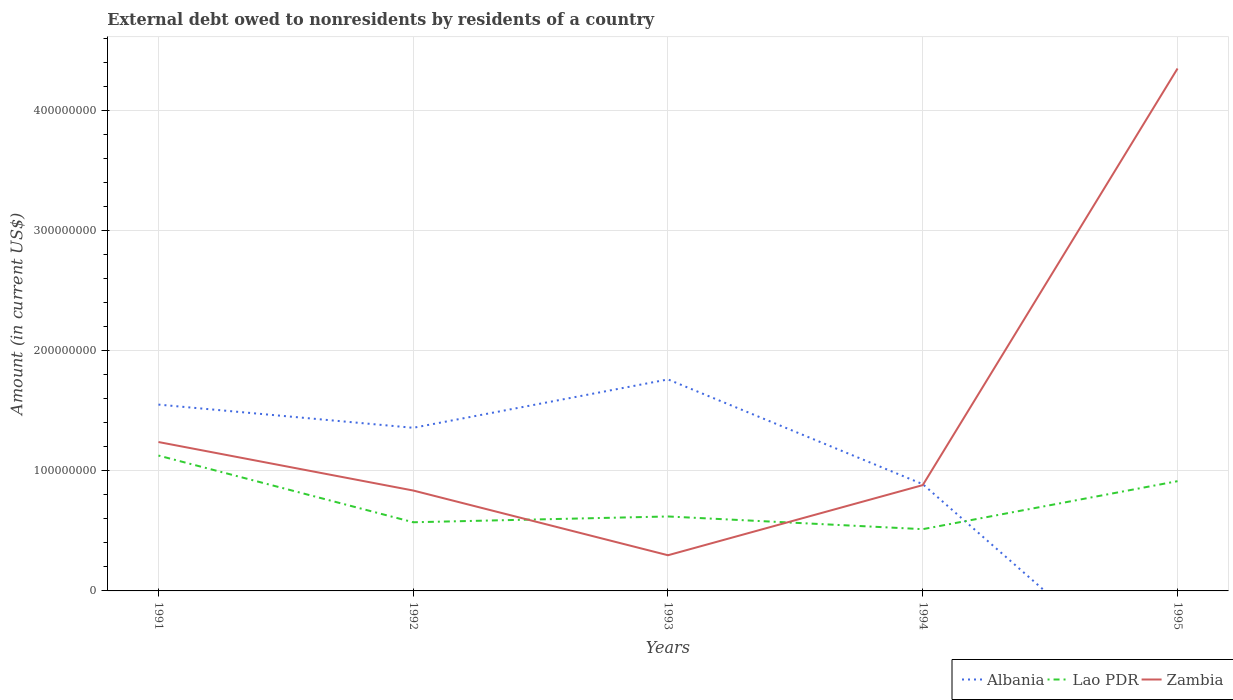Does the line corresponding to Albania intersect with the line corresponding to Lao PDR?
Make the answer very short. Yes. Across all years, what is the maximum external debt owed by residents in Lao PDR?
Provide a succinct answer. 5.14e+07. What is the total external debt owed by residents in Zambia in the graph?
Provide a short and direct response. -4.05e+08. What is the difference between the highest and the second highest external debt owed by residents in Albania?
Give a very brief answer. 1.76e+08. Is the external debt owed by residents in Zambia strictly greater than the external debt owed by residents in Albania over the years?
Ensure brevity in your answer.  No. How are the legend labels stacked?
Make the answer very short. Horizontal. What is the title of the graph?
Give a very brief answer. External debt owed to nonresidents by residents of a country. What is the label or title of the X-axis?
Provide a short and direct response. Years. What is the label or title of the Y-axis?
Keep it short and to the point. Amount (in current US$). What is the Amount (in current US$) in Albania in 1991?
Your answer should be very brief. 1.55e+08. What is the Amount (in current US$) of Lao PDR in 1991?
Provide a succinct answer. 1.13e+08. What is the Amount (in current US$) in Zambia in 1991?
Offer a terse response. 1.24e+08. What is the Amount (in current US$) of Albania in 1992?
Give a very brief answer. 1.36e+08. What is the Amount (in current US$) of Lao PDR in 1992?
Provide a succinct answer. 5.72e+07. What is the Amount (in current US$) in Zambia in 1992?
Keep it short and to the point. 8.36e+07. What is the Amount (in current US$) of Albania in 1993?
Keep it short and to the point. 1.76e+08. What is the Amount (in current US$) of Lao PDR in 1993?
Ensure brevity in your answer.  6.20e+07. What is the Amount (in current US$) in Zambia in 1993?
Provide a succinct answer. 2.97e+07. What is the Amount (in current US$) in Albania in 1994?
Provide a short and direct response. 8.89e+07. What is the Amount (in current US$) of Lao PDR in 1994?
Provide a succinct answer. 5.14e+07. What is the Amount (in current US$) in Zambia in 1994?
Offer a very short reply. 8.81e+07. What is the Amount (in current US$) in Lao PDR in 1995?
Give a very brief answer. 9.14e+07. What is the Amount (in current US$) in Zambia in 1995?
Your answer should be compact. 4.35e+08. Across all years, what is the maximum Amount (in current US$) in Albania?
Keep it short and to the point. 1.76e+08. Across all years, what is the maximum Amount (in current US$) in Lao PDR?
Ensure brevity in your answer.  1.13e+08. Across all years, what is the maximum Amount (in current US$) of Zambia?
Offer a very short reply. 4.35e+08. Across all years, what is the minimum Amount (in current US$) of Albania?
Ensure brevity in your answer.  0. Across all years, what is the minimum Amount (in current US$) of Lao PDR?
Provide a short and direct response. 5.14e+07. Across all years, what is the minimum Amount (in current US$) of Zambia?
Offer a terse response. 2.97e+07. What is the total Amount (in current US$) in Albania in the graph?
Your answer should be very brief. 5.56e+08. What is the total Amount (in current US$) of Lao PDR in the graph?
Offer a very short reply. 3.75e+08. What is the total Amount (in current US$) of Zambia in the graph?
Your answer should be compact. 7.60e+08. What is the difference between the Amount (in current US$) in Albania in 1991 and that in 1992?
Your answer should be very brief. 1.93e+07. What is the difference between the Amount (in current US$) of Lao PDR in 1991 and that in 1992?
Provide a succinct answer. 5.55e+07. What is the difference between the Amount (in current US$) of Zambia in 1991 and that in 1992?
Give a very brief answer. 4.04e+07. What is the difference between the Amount (in current US$) in Albania in 1991 and that in 1993?
Make the answer very short. -2.10e+07. What is the difference between the Amount (in current US$) of Lao PDR in 1991 and that in 1993?
Make the answer very short. 5.07e+07. What is the difference between the Amount (in current US$) of Zambia in 1991 and that in 1993?
Keep it short and to the point. 9.43e+07. What is the difference between the Amount (in current US$) of Albania in 1991 and that in 1994?
Provide a short and direct response. 6.63e+07. What is the difference between the Amount (in current US$) of Lao PDR in 1991 and that in 1994?
Provide a succinct answer. 6.13e+07. What is the difference between the Amount (in current US$) of Zambia in 1991 and that in 1994?
Offer a very short reply. 3.59e+07. What is the difference between the Amount (in current US$) of Lao PDR in 1991 and that in 1995?
Offer a terse response. 2.13e+07. What is the difference between the Amount (in current US$) of Zambia in 1991 and that in 1995?
Your response must be concise. -3.11e+08. What is the difference between the Amount (in current US$) in Albania in 1992 and that in 1993?
Your answer should be very brief. -4.03e+07. What is the difference between the Amount (in current US$) of Lao PDR in 1992 and that in 1993?
Give a very brief answer. -4.82e+06. What is the difference between the Amount (in current US$) in Zambia in 1992 and that in 1993?
Keep it short and to the point. 5.39e+07. What is the difference between the Amount (in current US$) in Albania in 1992 and that in 1994?
Your answer should be compact. 4.69e+07. What is the difference between the Amount (in current US$) of Lao PDR in 1992 and that in 1994?
Ensure brevity in your answer.  5.76e+06. What is the difference between the Amount (in current US$) in Zambia in 1992 and that in 1994?
Your response must be concise. -4.52e+06. What is the difference between the Amount (in current US$) in Lao PDR in 1992 and that in 1995?
Your response must be concise. -3.42e+07. What is the difference between the Amount (in current US$) of Zambia in 1992 and that in 1995?
Offer a very short reply. -3.51e+08. What is the difference between the Amount (in current US$) of Albania in 1993 and that in 1994?
Offer a terse response. 8.72e+07. What is the difference between the Amount (in current US$) in Lao PDR in 1993 and that in 1994?
Provide a short and direct response. 1.06e+07. What is the difference between the Amount (in current US$) of Zambia in 1993 and that in 1994?
Make the answer very short. -5.84e+07. What is the difference between the Amount (in current US$) of Lao PDR in 1993 and that in 1995?
Give a very brief answer. -2.94e+07. What is the difference between the Amount (in current US$) of Zambia in 1993 and that in 1995?
Give a very brief answer. -4.05e+08. What is the difference between the Amount (in current US$) in Lao PDR in 1994 and that in 1995?
Provide a short and direct response. -4.00e+07. What is the difference between the Amount (in current US$) in Zambia in 1994 and that in 1995?
Offer a terse response. -3.47e+08. What is the difference between the Amount (in current US$) in Albania in 1991 and the Amount (in current US$) in Lao PDR in 1992?
Ensure brevity in your answer.  9.80e+07. What is the difference between the Amount (in current US$) of Albania in 1991 and the Amount (in current US$) of Zambia in 1992?
Your answer should be very brief. 7.15e+07. What is the difference between the Amount (in current US$) of Lao PDR in 1991 and the Amount (in current US$) of Zambia in 1992?
Give a very brief answer. 2.91e+07. What is the difference between the Amount (in current US$) in Albania in 1991 and the Amount (in current US$) in Lao PDR in 1993?
Your answer should be very brief. 9.31e+07. What is the difference between the Amount (in current US$) of Albania in 1991 and the Amount (in current US$) of Zambia in 1993?
Your response must be concise. 1.25e+08. What is the difference between the Amount (in current US$) in Lao PDR in 1991 and the Amount (in current US$) in Zambia in 1993?
Offer a terse response. 8.30e+07. What is the difference between the Amount (in current US$) of Albania in 1991 and the Amount (in current US$) of Lao PDR in 1994?
Make the answer very short. 1.04e+08. What is the difference between the Amount (in current US$) in Albania in 1991 and the Amount (in current US$) in Zambia in 1994?
Ensure brevity in your answer.  6.70e+07. What is the difference between the Amount (in current US$) in Lao PDR in 1991 and the Amount (in current US$) in Zambia in 1994?
Give a very brief answer. 2.46e+07. What is the difference between the Amount (in current US$) in Albania in 1991 and the Amount (in current US$) in Lao PDR in 1995?
Offer a very short reply. 6.38e+07. What is the difference between the Amount (in current US$) in Albania in 1991 and the Amount (in current US$) in Zambia in 1995?
Your response must be concise. -2.80e+08. What is the difference between the Amount (in current US$) of Lao PDR in 1991 and the Amount (in current US$) of Zambia in 1995?
Your answer should be very brief. -3.22e+08. What is the difference between the Amount (in current US$) in Albania in 1992 and the Amount (in current US$) in Lao PDR in 1993?
Give a very brief answer. 7.38e+07. What is the difference between the Amount (in current US$) of Albania in 1992 and the Amount (in current US$) of Zambia in 1993?
Provide a succinct answer. 1.06e+08. What is the difference between the Amount (in current US$) of Lao PDR in 1992 and the Amount (in current US$) of Zambia in 1993?
Your answer should be very brief. 2.75e+07. What is the difference between the Amount (in current US$) of Albania in 1992 and the Amount (in current US$) of Lao PDR in 1994?
Your answer should be very brief. 8.44e+07. What is the difference between the Amount (in current US$) in Albania in 1992 and the Amount (in current US$) in Zambia in 1994?
Offer a very short reply. 4.77e+07. What is the difference between the Amount (in current US$) of Lao PDR in 1992 and the Amount (in current US$) of Zambia in 1994?
Offer a terse response. -3.09e+07. What is the difference between the Amount (in current US$) of Albania in 1992 and the Amount (in current US$) of Lao PDR in 1995?
Give a very brief answer. 4.44e+07. What is the difference between the Amount (in current US$) of Albania in 1992 and the Amount (in current US$) of Zambia in 1995?
Keep it short and to the point. -2.99e+08. What is the difference between the Amount (in current US$) of Lao PDR in 1992 and the Amount (in current US$) of Zambia in 1995?
Offer a very short reply. -3.78e+08. What is the difference between the Amount (in current US$) in Albania in 1993 and the Amount (in current US$) in Lao PDR in 1994?
Your answer should be very brief. 1.25e+08. What is the difference between the Amount (in current US$) of Albania in 1993 and the Amount (in current US$) of Zambia in 1994?
Your answer should be very brief. 8.80e+07. What is the difference between the Amount (in current US$) in Lao PDR in 1993 and the Amount (in current US$) in Zambia in 1994?
Your answer should be compact. -2.61e+07. What is the difference between the Amount (in current US$) in Albania in 1993 and the Amount (in current US$) in Lao PDR in 1995?
Your answer should be compact. 8.47e+07. What is the difference between the Amount (in current US$) in Albania in 1993 and the Amount (in current US$) in Zambia in 1995?
Offer a terse response. -2.59e+08. What is the difference between the Amount (in current US$) in Lao PDR in 1993 and the Amount (in current US$) in Zambia in 1995?
Offer a very short reply. -3.73e+08. What is the difference between the Amount (in current US$) of Albania in 1994 and the Amount (in current US$) of Lao PDR in 1995?
Your answer should be compact. -2.50e+06. What is the difference between the Amount (in current US$) in Albania in 1994 and the Amount (in current US$) in Zambia in 1995?
Provide a short and direct response. -3.46e+08. What is the difference between the Amount (in current US$) in Lao PDR in 1994 and the Amount (in current US$) in Zambia in 1995?
Make the answer very short. -3.84e+08. What is the average Amount (in current US$) in Albania per year?
Offer a very short reply. 1.11e+08. What is the average Amount (in current US$) in Lao PDR per year?
Your answer should be compact. 7.49e+07. What is the average Amount (in current US$) in Zambia per year?
Offer a very short reply. 1.52e+08. In the year 1991, what is the difference between the Amount (in current US$) in Albania and Amount (in current US$) in Lao PDR?
Make the answer very short. 4.24e+07. In the year 1991, what is the difference between the Amount (in current US$) of Albania and Amount (in current US$) of Zambia?
Your answer should be very brief. 3.12e+07. In the year 1991, what is the difference between the Amount (in current US$) in Lao PDR and Amount (in current US$) in Zambia?
Keep it short and to the point. -1.13e+07. In the year 1992, what is the difference between the Amount (in current US$) of Albania and Amount (in current US$) of Lao PDR?
Your answer should be compact. 7.86e+07. In the year 1992, what is the difference between the Amount (in current US$) in Albania and Amount (in current US$) in Zambia?
Your answer should be compact. 5.22e+07. In the year 1992, what is the difference between the Amount (in current US$) in Lao PDR and Amount (in current US$) in Zambia?
Make the answer very short. -2.64e+07. In the year 1993, what is the difference between the Amount (in current US$) of Albania and Amount (in current US$) of Lao PDR?
Your answer should be very brief. 1.14e+08. In the year 1993, what is the difference between the Amount (in current US$) in Albania and Amount (in current US$) in Zambia?
Give a very brief answer. 1.46e+08. In the year 1993, what is the difference between the Amount (in current US$) in Lao PDR and Amount (in current US$) in Zambia?
Your response must be concise. 3.23e+07. In the year 1994, what is the difference between the Amount (in current US$) in Albania and Amount (in current US$) in Lao PDR?
Provide a succinct answer. 3.75e+07. In the year 1994, what is the difference between the Amount (in current US$) in Albania and Amount (in current US$) in Zambia?
Your answer should be compact. 7.77e+05. In the year 1994, what is the difference between the Amount (in current US$) in Lao PDR and Amount (in current US$) in Zambia?
Your response must be concise. -3.67e+07. In the year 1995, what is the difference between the Amount (in current US$) in Lao PDR and Amount (in current US$) in Zambia?
Your answer should be very brief. -3.44e+08. What is the ratio of the Amount (in current US$) of Albania in 1991 to that in 1992?
Provide a succinct answer. 1.14. What is the ratio of the Amount (in current US$) of Lao PDR in 1991 to that in 1992?
Your answer should be very brief. 1.97. What is the ratio of the Amount (in current US$) of Zambia in 1991 to that in 1992?
Your answer should be compact. 1.48. What is the ratio of the Amount (in current US$) of Albania in 1991 to that in 1993?
Provide a short and direct response. 0.88. What is the ratio of the Amount (in current US$) of Lao PDR in 1991 to that in 1993?
Ensure brevity in your answer.  1.82. What is the ratio of the Amount (in current US$) in Zambia in 1991 to that in 1993?
Ensure brevity in your answer.  4.17. What is the ratio of the Amount (in current US$) in Albania in 1991 to that in 1994?
Provide a short and direct response. 1.75. What is the ratio of the Amount (in current US$) in Lao PDR in 1991 to that in 1994?
Ensure brevity in your answer.  2.19. What is the ratio of the Amount (in current US$) in Zambia in 1991 to that in 1994?
Offer a very short reply. 1.41. What is the ratio of the Amount (in current US$) in Lao PDR in 1991 to that in 1995?
Your answer should be very brief. 1.23. What is the ratio of the Amount (in current US$) in Zambia in 1991 to that in 1995?
Your answer should be compact. 0.28. What is the ratio of the Amount (in current US$) of Albania in 1992 to that in 1993?
Provide a short and direct response. 0.77. What is the ratio of the Amount (in current US$) of Lao PDR in 1992 to that in 1993?
Keep it short and to the point. 0.92. What is the ratio of the Amount (in current US$) of Zambia in 1992 to that in 1993?
Offer a very short reply. 2.81. What is the ratio of the Amount (in current US$) of Albania in 1992 to that in 1994?
Provide a short and direct response. 1.53. What is the ratio of the Amount (in current US$) in Lao PDR in 1992 to that in 1994?
Keep it short and to the point. 1.11. What is the ratio of the Amount (in current US$) of Zambia in 1992 to that in 1994?
Keep it short and to the point. 0.95. What is the ratio of the Amount (in current US$) in Lao PDR in 1992 to that in 1995?
Offer a terse response. 0.63. What is the ratio of the Amount (in current US$) of Zambia in 1992 to that in 1995?
Your answer should be very brief. 0.19. What is the ratio of the Amount (in current US$) of Albania in 1993 to that in 1994?
Your answer should be very brief. 1.98. What is the ratio of the Amount (in current US$) of Lao PDR in 1993 to that in 1994?
Make the answer very short. 1.21. What is the ratio of the Amount (in current US$) of Zambia in 1993 to that in 1994?
Make the answer very short. 0.34. What is the ratio of the Amount (in current US$) of Lao PDR in 1993 to that in 1995?
Your response must be concise. 0.68. What is the ratio of the Amount (in current US$) of Zambia in 1993 to that in 1995?
Keep it short and to the point. 0.07. What is the ratio of the Amount (in current US$) in Lao PDR in 1994 to that in 1995?
Your response must be concise. 0.56. What is the ratio of the Amount (in current US$) in Zambia in 1994 to that in 1995?
Ensure brevity in your answer.  0.2. What is the difference between the highest and the second highest Amount (in current US$) of Albania?
Offer a very short reply. 2.10e+07. What is the difference between the highest and the second highest Amount (in current US$) in Lao PDR?
Make the answer very short. 2.13e+07. What is the difference between the highest and the second highest Amount (in current US$) of Zambia?
Your answer should be very brief. 3.11e+08. What is the difference between the highest and the lowest Amount (in current US$) in Albania?
Offer a terse response. 1.76e+08. What is the difference between the highest and the lowest Amount (in current US$) of Lao PDR?
Your answer should be compact. 6.13e+07. What is the difference between the highest and the lowest Amount (in current US$) of Zambia?
Keep it short and to the point. 4.05e+08. 